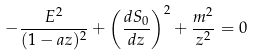Convert formula to latex. <formula><loc_0><loc_0><loc_500><loc_500>- \frac { E ^ { 2 } } { ( 1 - a z ) ^ { 2 } } + \left ( \frac { d S _ { 0 } } { d z } \right ) ^ { 2 } + \frac { m ^ { 2 } } { z ^ { 2 } } = 0</formula> 